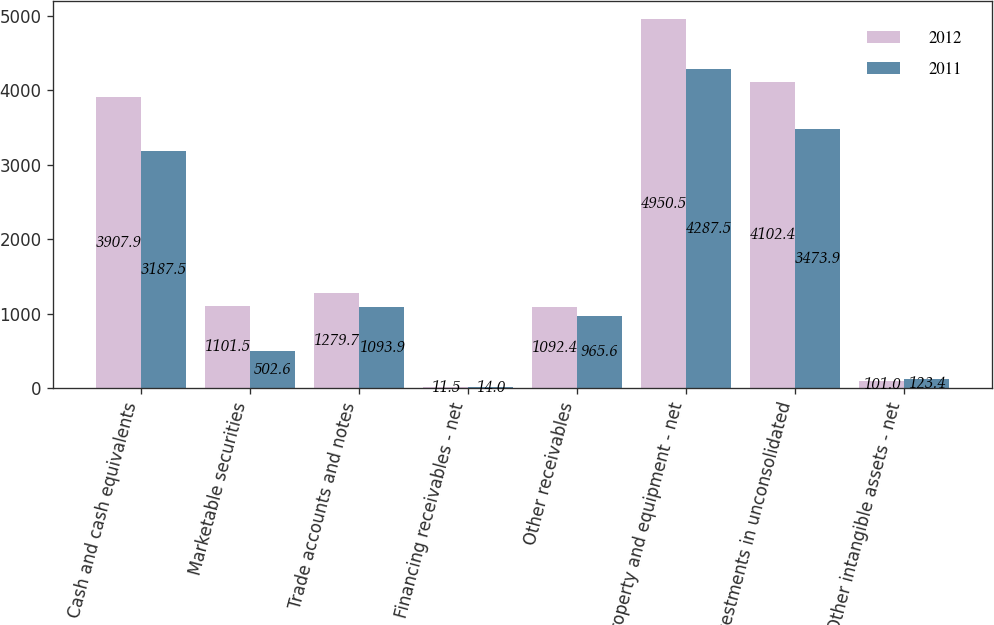Convert chart. <chart><loc_0><loc_0><loc_500><loc_500><stacked_bar_chart><ecel><fcel>Cash and cash equivalents<fcel>Marketable securities<fcel>Trade accounts and notes<fcel>Financing receivables - net<fcel>Other receivables<fcel>Property and equipment - net<fcel>Investments in unconsolidated<fcel>Other intangible assets - net<nl><fcel>2012<fcel>3907.9<fcel>1101.5<fcel>1279.7<fcel>11.5<fcel>1092.4<fcel>4950.5<fcel>4102.4<fcel>101<nl><fcel>2011<fcel>3187.5<fcel>502.6<fcel>1093.9<fcel>14<fcel>965.6<fcel>4287.5<fcel>3473.9<fcel>123.4<nl></chart> 